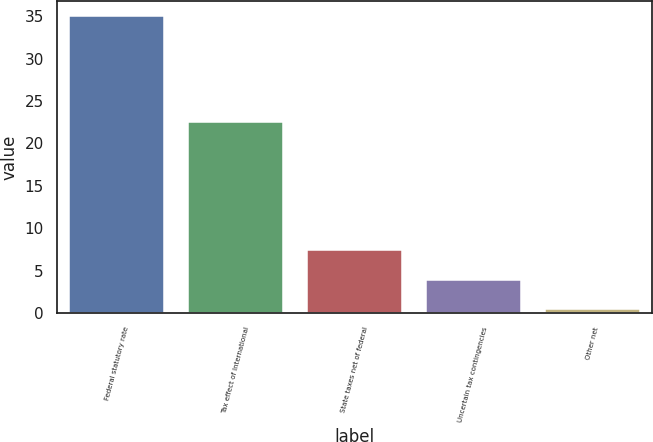Convert chart. <chart><loc_0><loc_0><loc_500><loc_500><bar_chart><fcel>Federal statutory rate<fcel>Tax effect of International<fcel>State taxes net of federal<fcel>Uncertain tax contingencies<fcel>Other net<nl><fcel>35<fcel>22.54<fcel>7.37<fcel>3.92<fcel>0.47<nl></chart> 